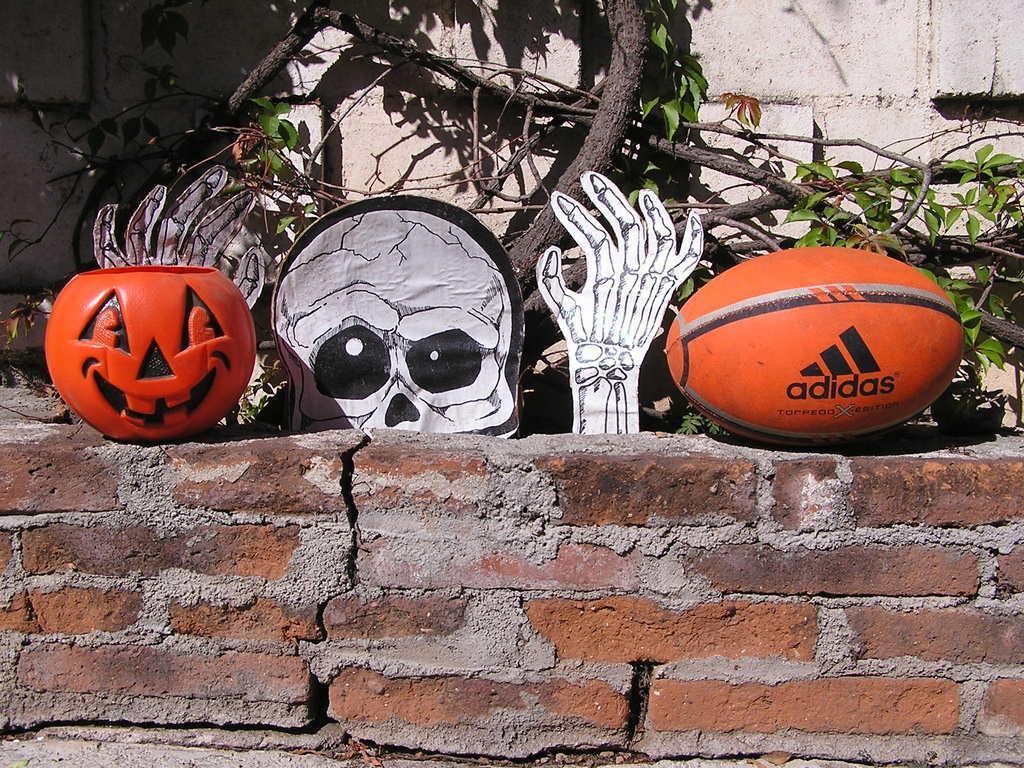Describe this image in one or two sentences. In the foreground of the picture there is a brick wall, on the wall there are ball pumpkin and a toy. In the background there are trees and a wall. It is sunny. 